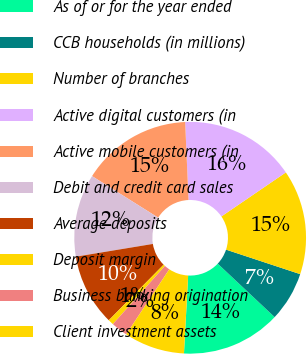Convert chart. <chart><loc_0><loc_0><loc_500><loc_500><pie_chart><fcel>As of or for the year ended<fcel>CCB households (in millions)<fcel>Number of branches<fcel>Active digital customers (in<fcel>Active mobile customers (in<fcel>Debit and credit card sales<fcel>Average deposits<fcel>Deposit margin<fcel>Business banking origination<fcel>Client investment assets<nl><fcel>13.85%<fcel>6.92%<fcel>14.62%<fcel>16.15%<fcel>15.38%<fcel>11.54%<fcel>10.0%<fcel>0.77%<fcel>2.31%<fcel>8.46%<nl></chart> 